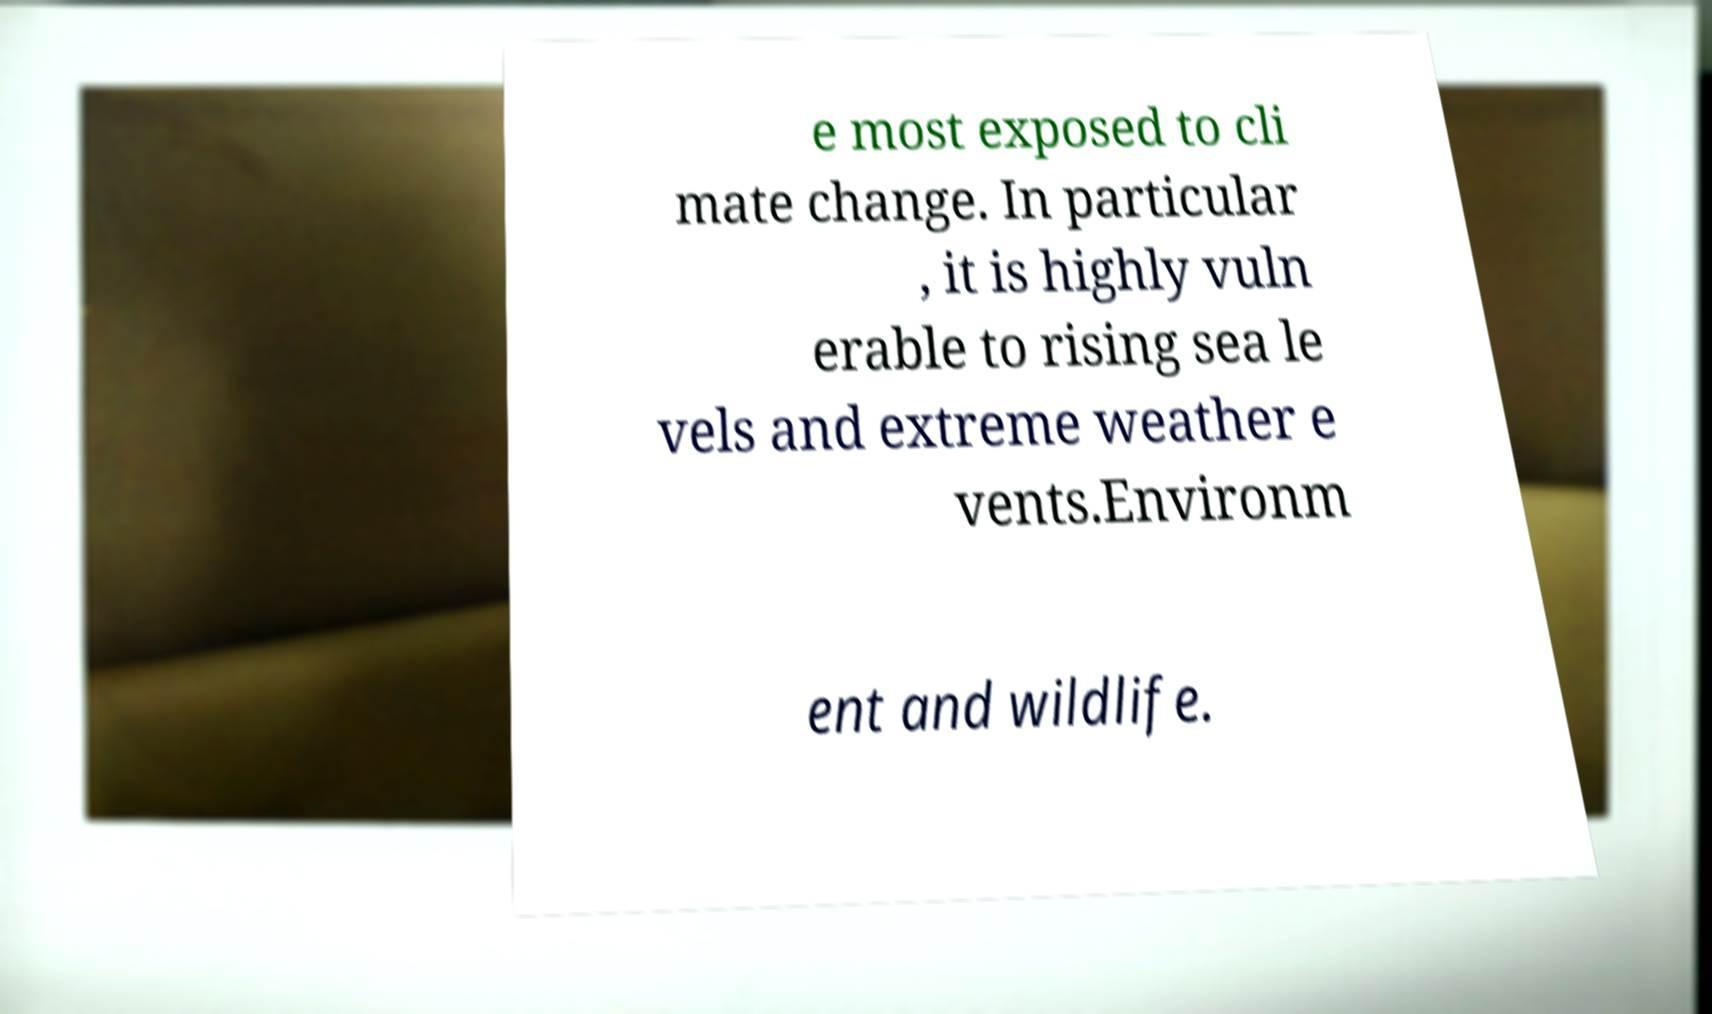Could you extract and type out the text from this image? e most exposed to cli mate change. In particular , it is highly vuln erable to rising sea le vels and extreme weather e vents.Environm ent and wildlife. 